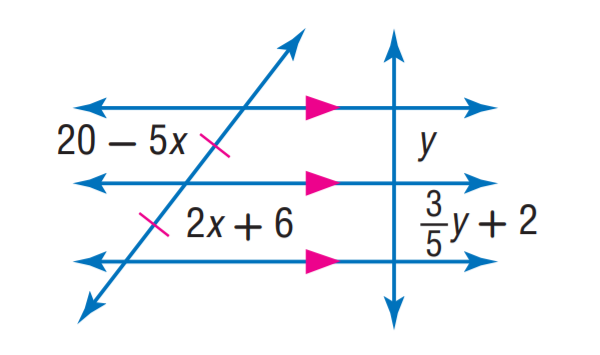Answer the mathemtical geometry problem and directly provide the correct option letter.
Question: Find y.
Choices: A: 2 B: 3 C: 4 D: 5 D 